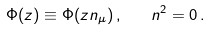<formula> <loc_0><loc_0><loc_500><loc_500>\Phi ( z ) \equiv \Phi ( z n _ { \mu } ) \, , \quad n ^ { 2 } = 0 \, .</formula> 